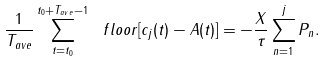<formula> <loc_0><loc_0><loc_500><loc_500>\frac { 1 } { T _ { a v e } } \sum _ { t = t _ { 0 } } ^ { t _ { 0 } + T _ { a v e } - 1 } \ f l o o r [ c _ { j } ( t ) - A ( t ) ] = - \frac { X } { \tau } \sum _ { n = 1 } ^ { j } P _ { n } .</formula> 